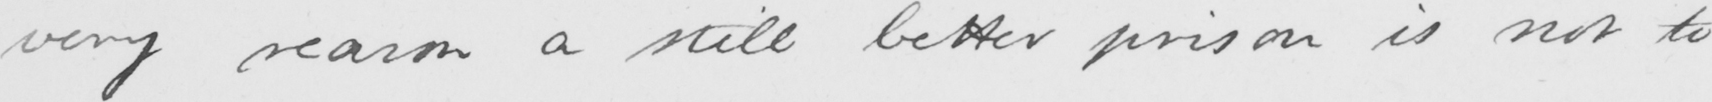Can you tell me what this handwritten text says? very reason a still better prison is not to 